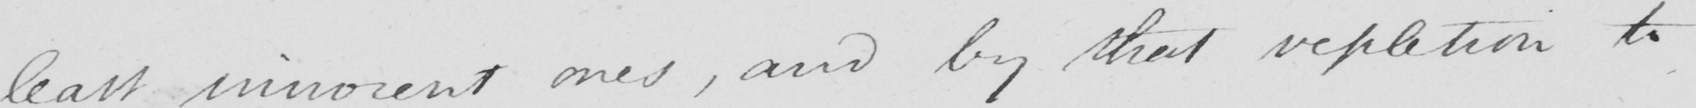Transcribe the text shown in this historical manuscript line. least innocent ones , and by that repletion to 